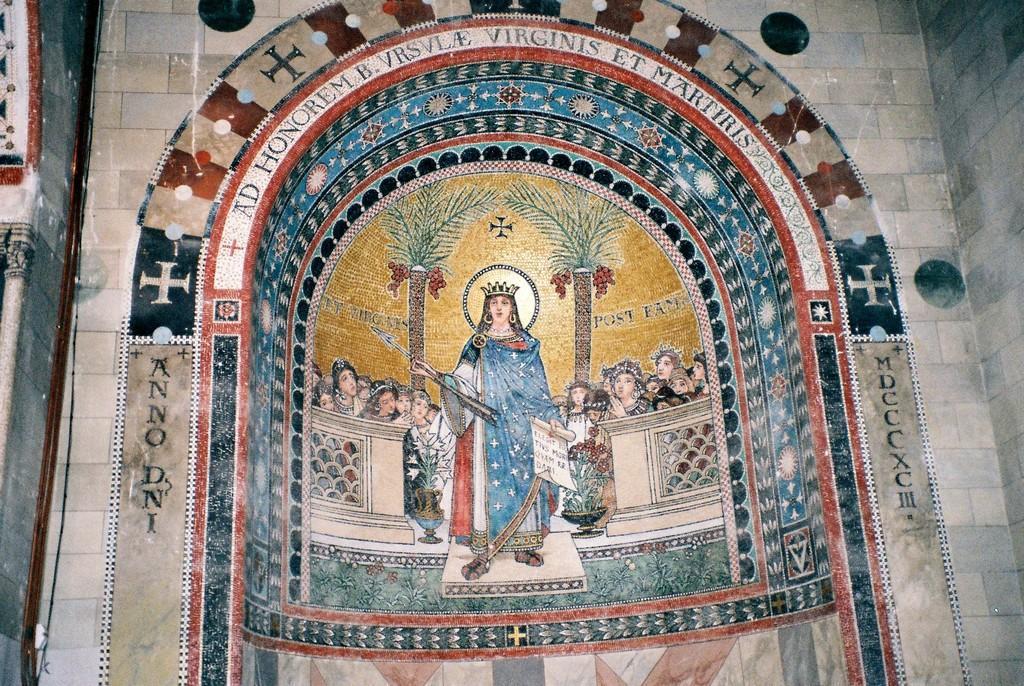In one or two sentences, can you explain what this image depicts? In this image I can see wall painting. In the painting I can see the group of people and one person standing and wearing the blue color dress and also the crown. The person is holding the weapon and the paper. In the back there are trees and I can also see something is written on the wall. 